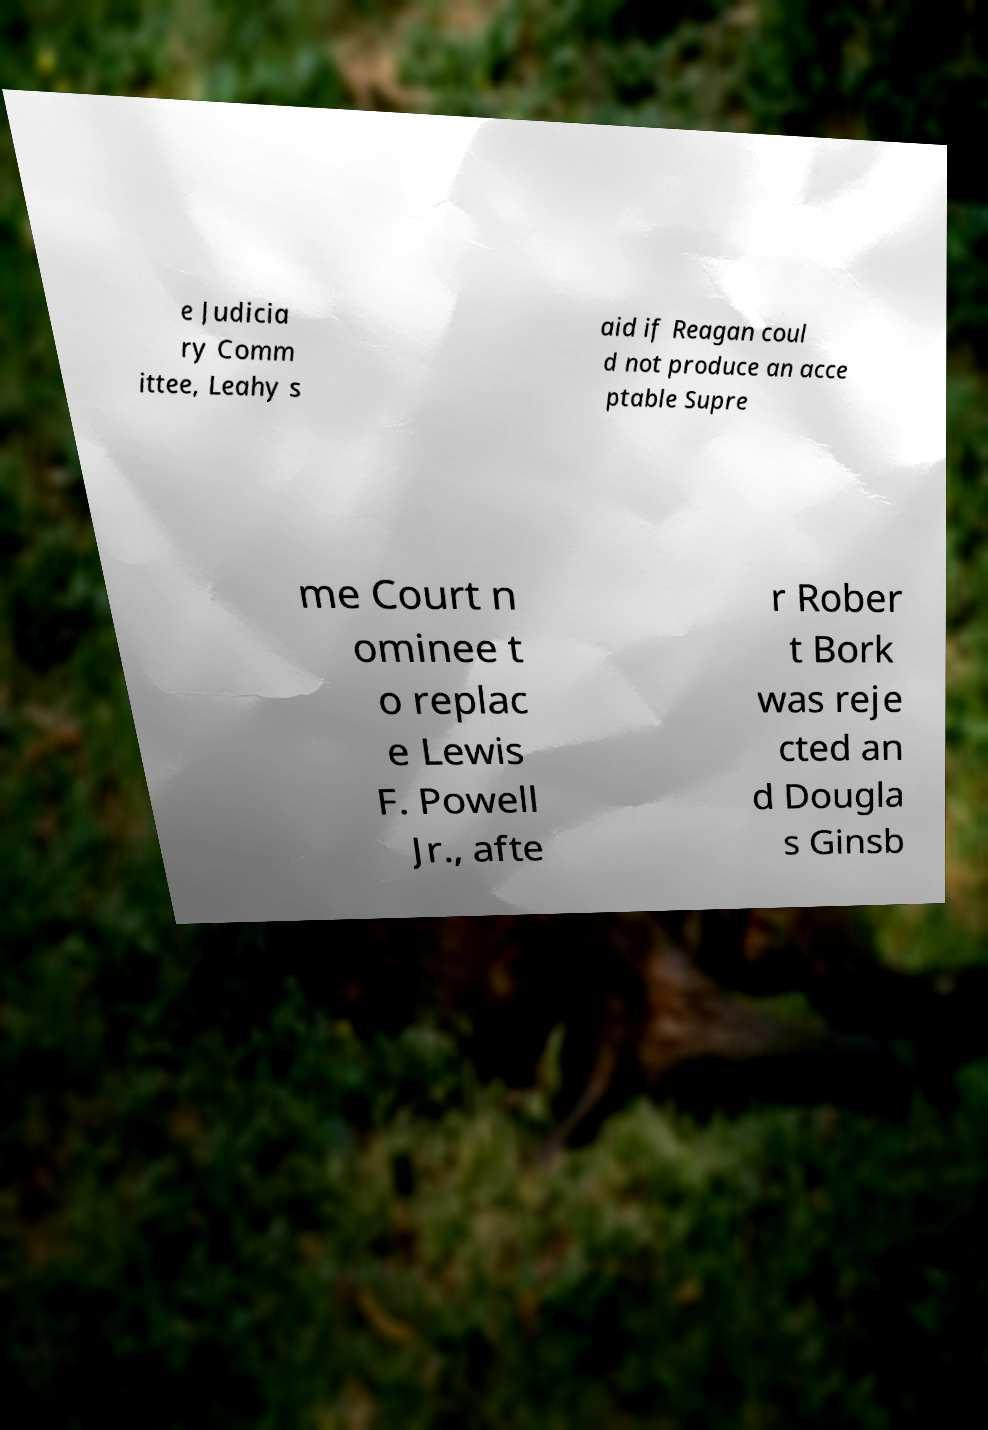I need the written content from this picture converted into text. Can you do that? e Judicia ry Comm ittee, Leahy s aid if Reagan coul d not produce an acce ptable Supre me Court n ominee t o replac e Lewis F. Powell Jr., afte r Rober t Bork was reje cted an d Dougla s Ginsb 